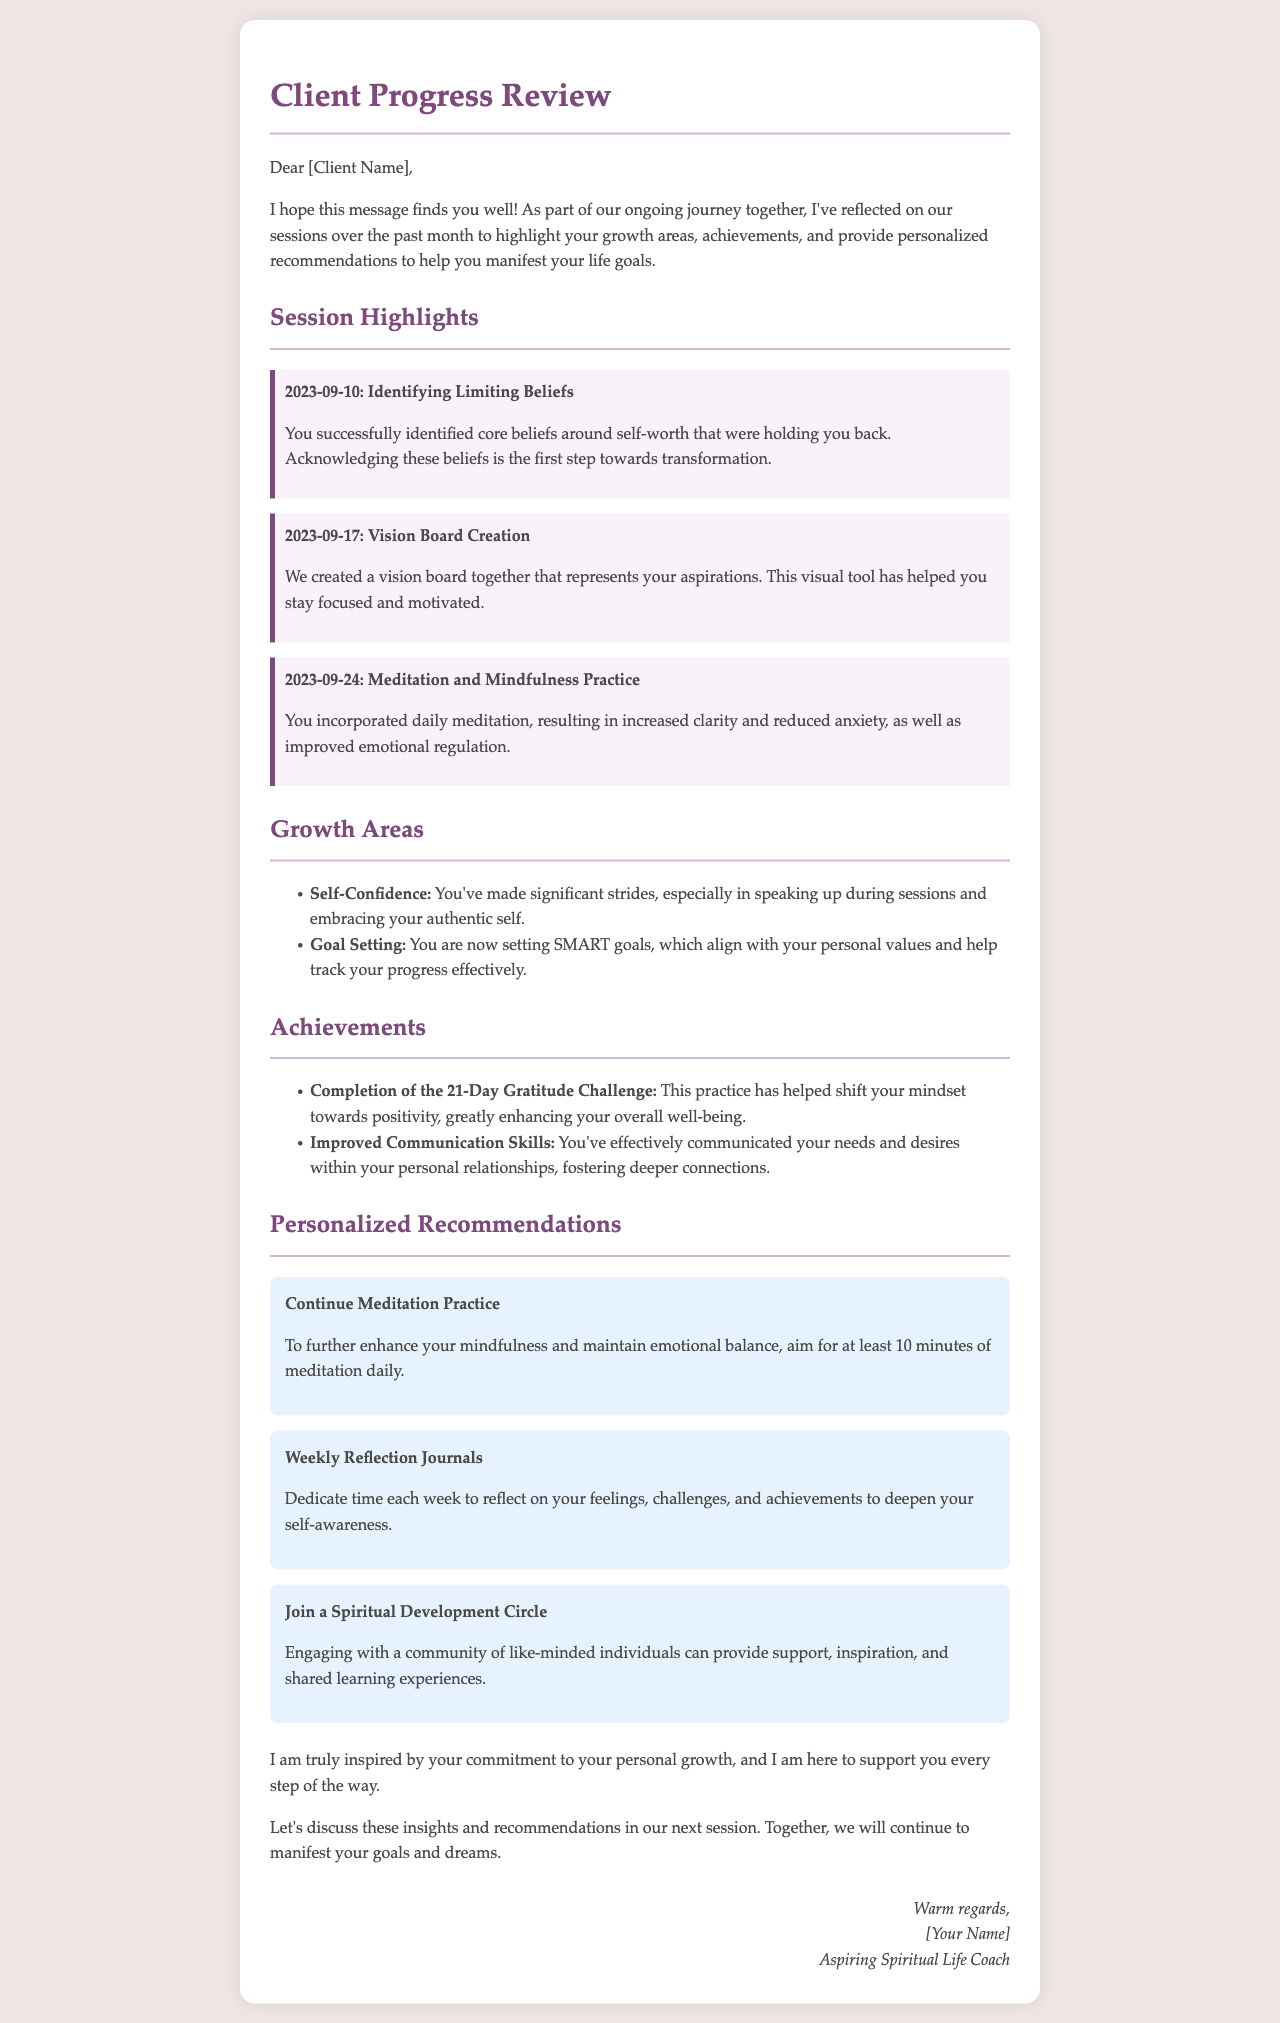What was the date when core beliefs were identified? The document states that core beliefs around self-worth were identified on September 10, 2023.
Answer: September 10, 2023 What is one of the highlights from the session on September 24? The highlight from the session on September 24 is the incorporation of daily meditation, which resulted in increased clarity and reduced anxiety.
Answer: Daily meditation What is one achievement mentioned in the review? The document lists "Completion of the 21-Day Gratitude Challenge" as one of the client's achievements.
Answer: Completion of the 21-Day Gratitude Challenge How many personalized recommendations are provided? The document outlines three personalized recommendations for the client to follow.
Answer: Three What area of growth involves setting SMART goals? The area of growth associated with setting SMART goals is named "Goal Setting."
Answer: Goal Setting What is the suggested daily duration for meditation practice? The recommendation advises aiming for at least 10 minutes of meditation daily to enhance mindfulness and emotional balance.
Answer: 10 minutes What type of circles does the document suggest joining? It mentions joining a "Spiritual Development Circle" to engage with a community of like-minded individuals.
Answer: Spiritual Development Circle What is the tone of the closing remarks in the document? The closing remarks express a tone of inspiration and support towards the client's personal growth journey.
Answer: Inspirational 